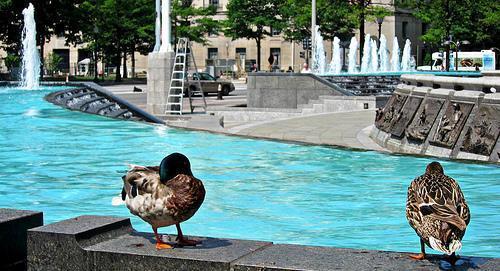How many birds are there?
Give a very brief answer. 2. 